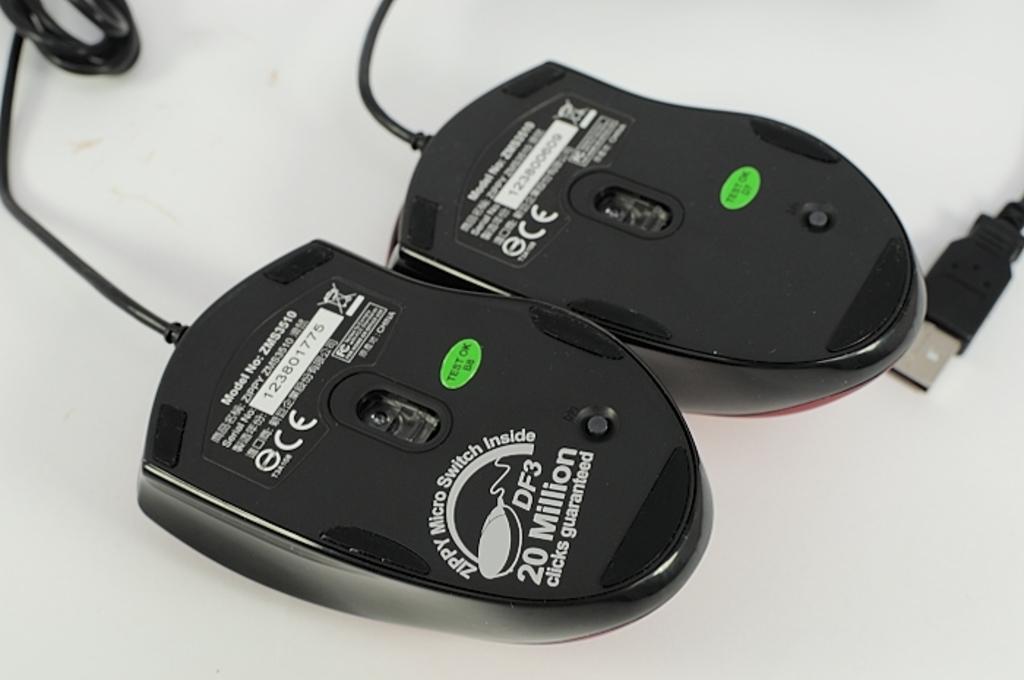How many guaranteed clicks?
Your answer should be compact. 20 million. What is the brand?
Ensure brevity in your answer.  Unanswerable. 